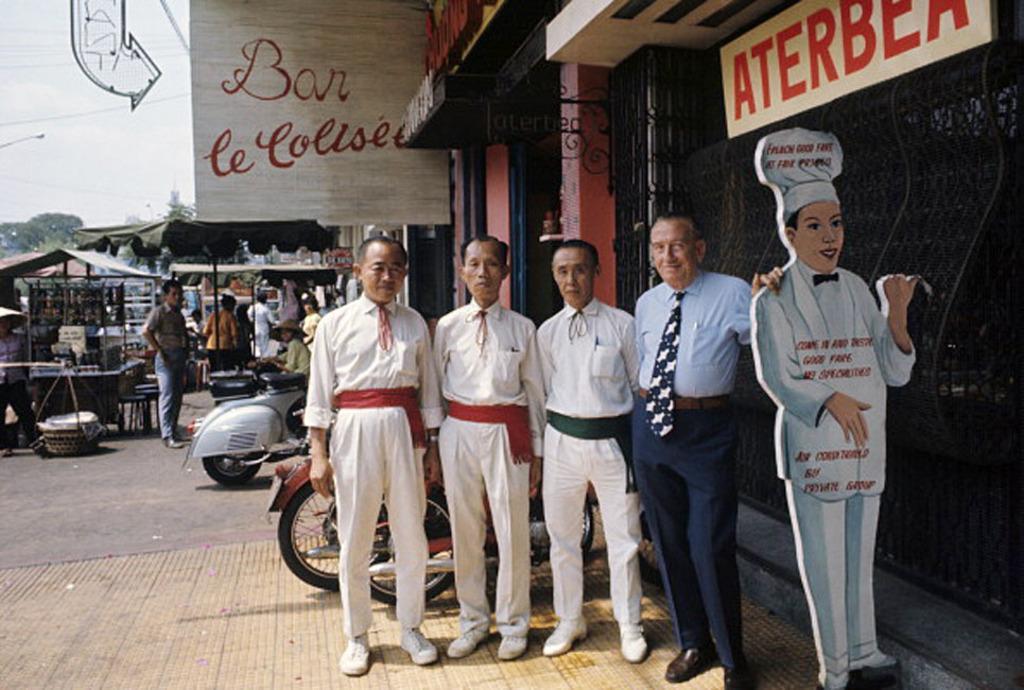Please provide a concise description of this image. On the right side there is a doll in the shape of a cook, beside it a man is standing, he wore shirt, tie, trouser, shoes. Beside him 3 men are standing, they wore white color dresses, behind them there are vehicle that are parked, on the left side there is an umbrella. 